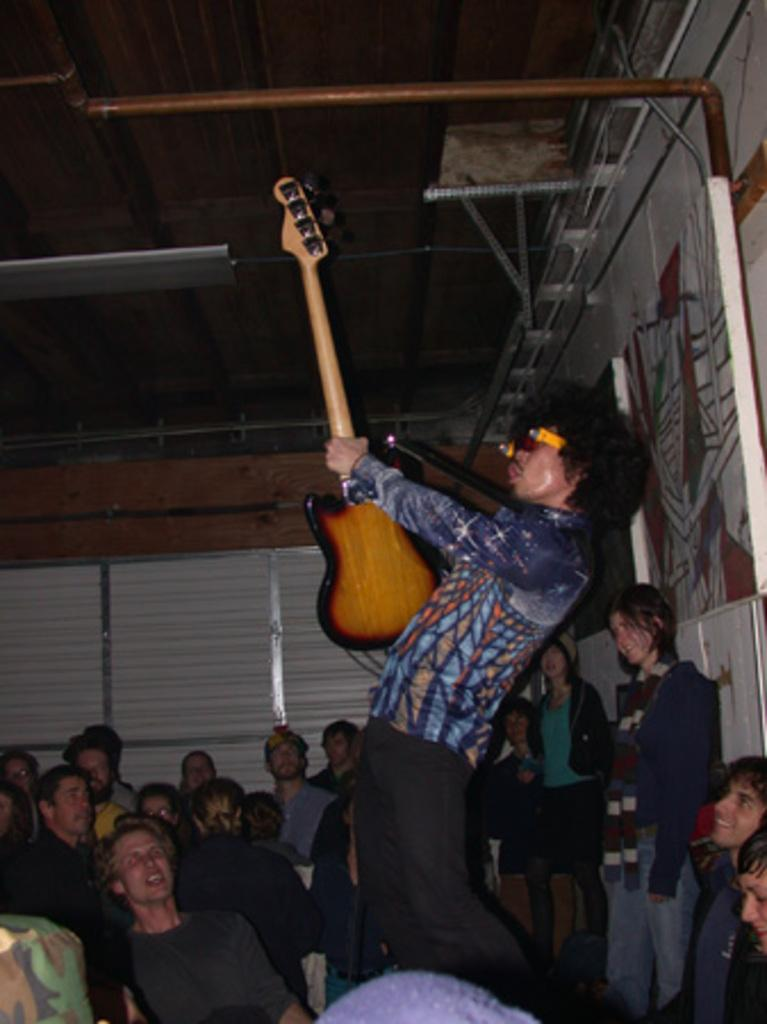What is the setting of the image? The image is set in a room. How many people are in the image? There are multiple persons in the image. What is the man in the image doing? The man is standing and playing the guitar. What are the other persons in the image doing? The other persons are watching the guitar performance. What type of caption is written on the wall in the image? There is no caption written on the wall in the image. What form does the earth take in the image? The image does not depict the earth; it is set in a room with people and a guitar performance. 